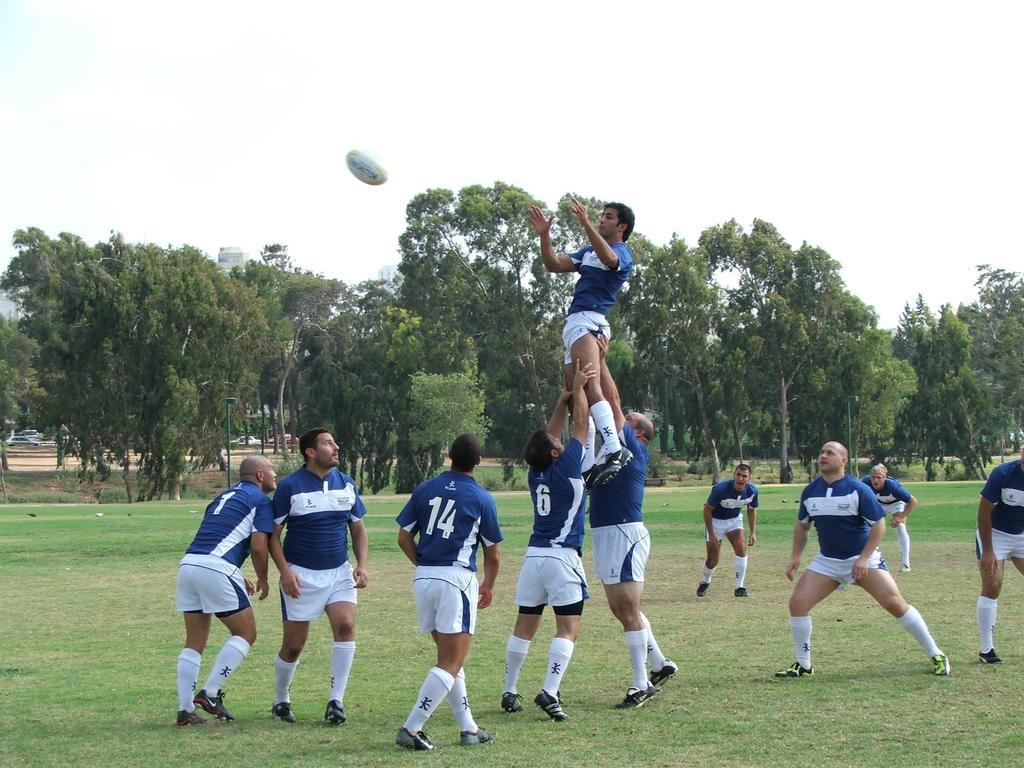<image>
Give a short and clear explanation of the subsequent image. Some men play rugby, one of whom has the number 14 on it. 